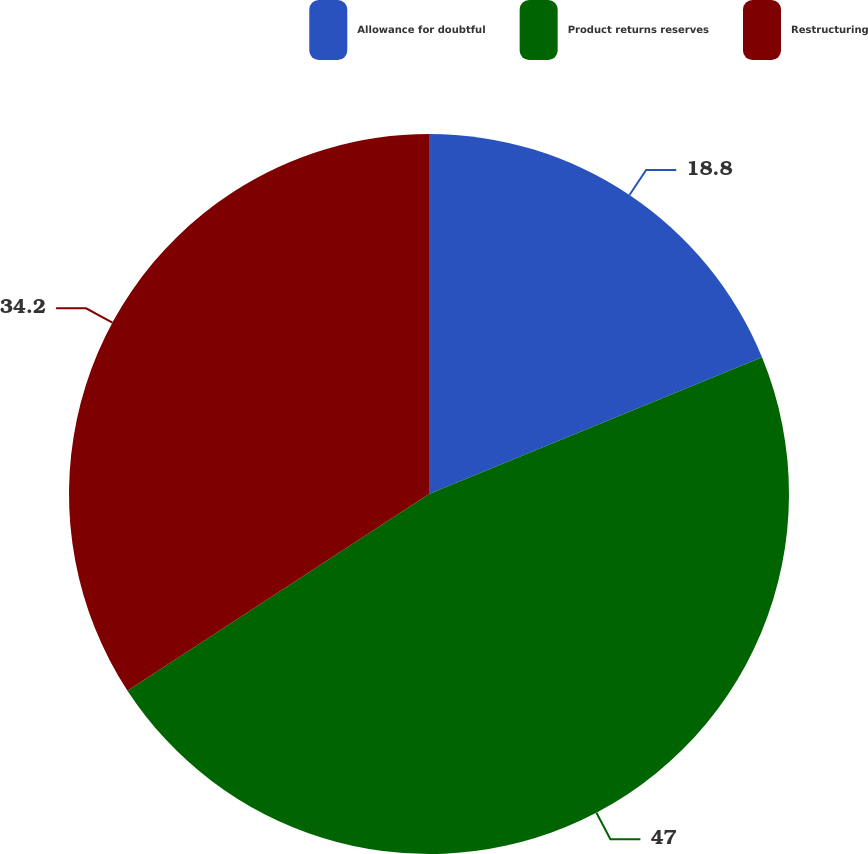Convert chart to OTSL. <chart><loc_0><loc_0><loc_500><loc_500><pie_chart><fcel>Allowance for doubtful<fcel>Product returns reserves<fcel>Restructuring<nl><fcel>18.8%<fcel>47.0%<fcel>34.2%<nl></chart> 